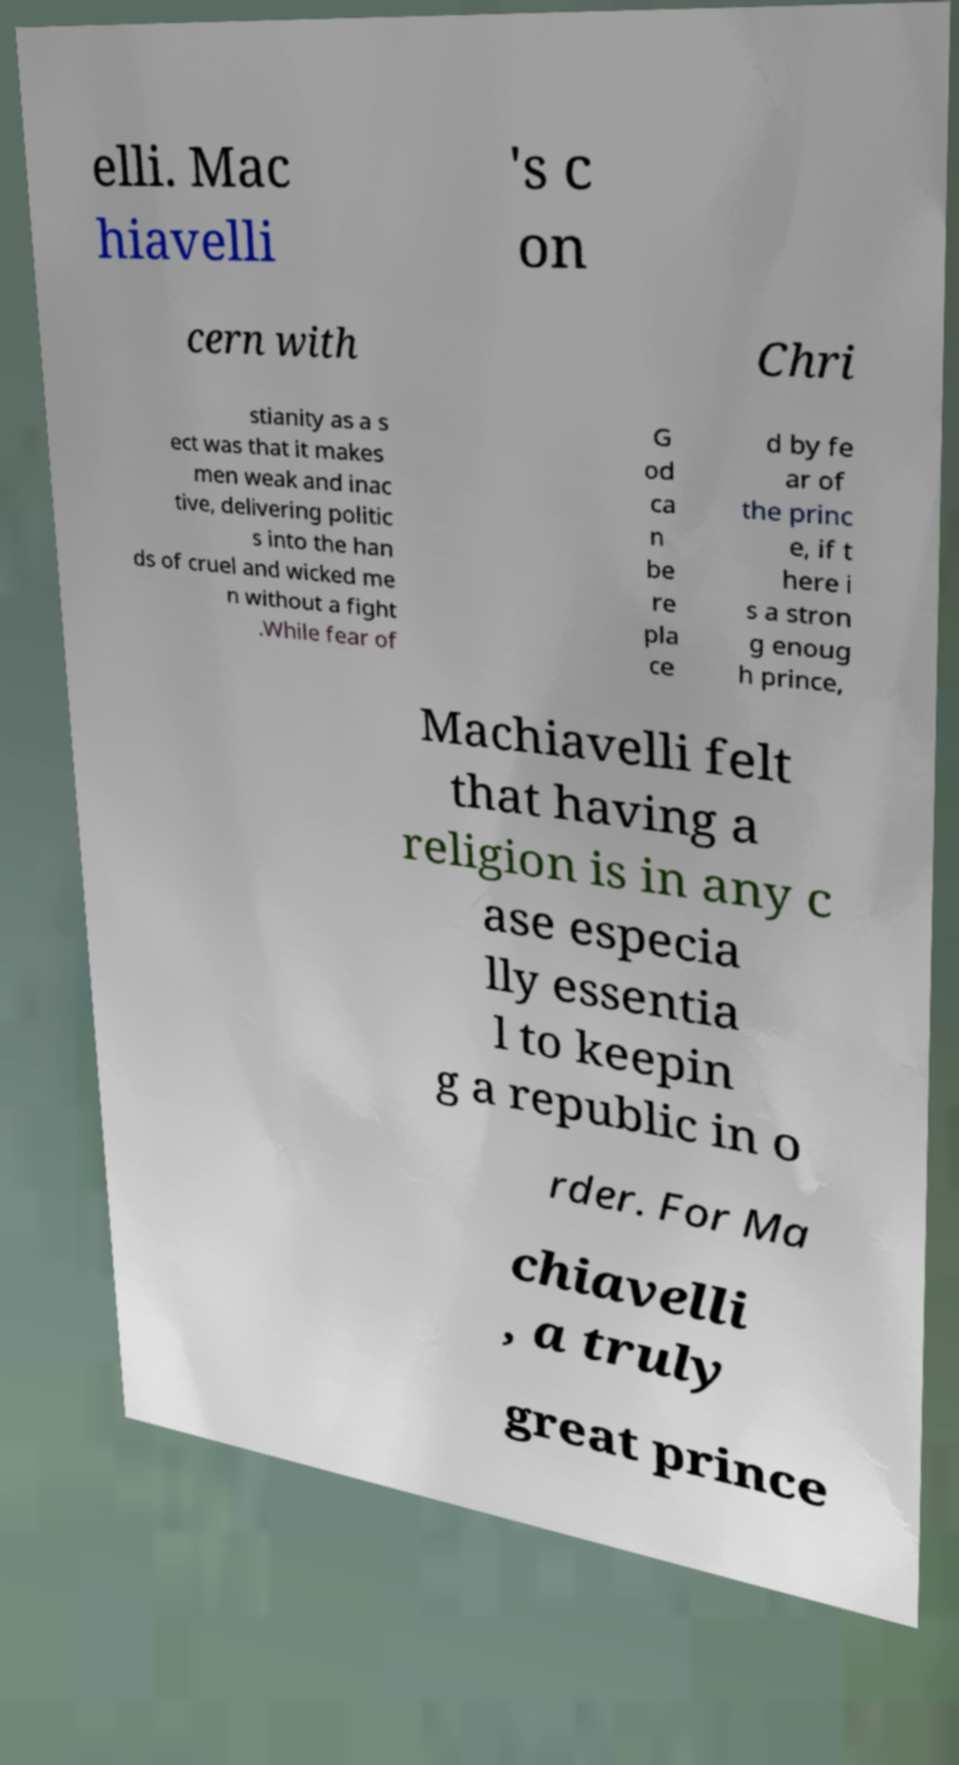I need the written content from this picture converted into text. Can you do that? elli. Mac hiavelli 's c on cern with Chri stianity as a s ect was that it makes men weak and inac tive, delivering politic s into the han ds of cruel and wicked me n without a fight .While fear of G od ca n be re pla ce d by fe ar of the princ e, if t here i s a stron g enoug h prince, Machiavelli felt that having a religion is in any c ase especia lly essentia l to keepin g a republic in o rder. For Ma chiavelli , a truly great prince 